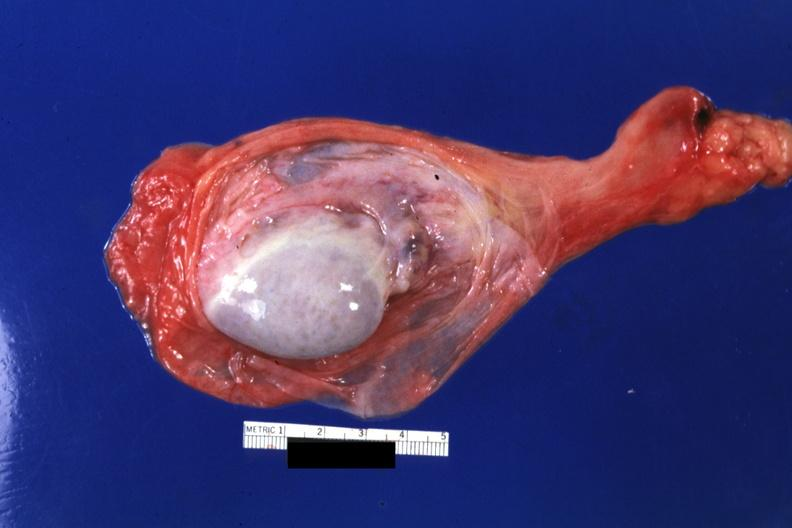s testicle present?
Answer the question using a single word or phrase. Yes 